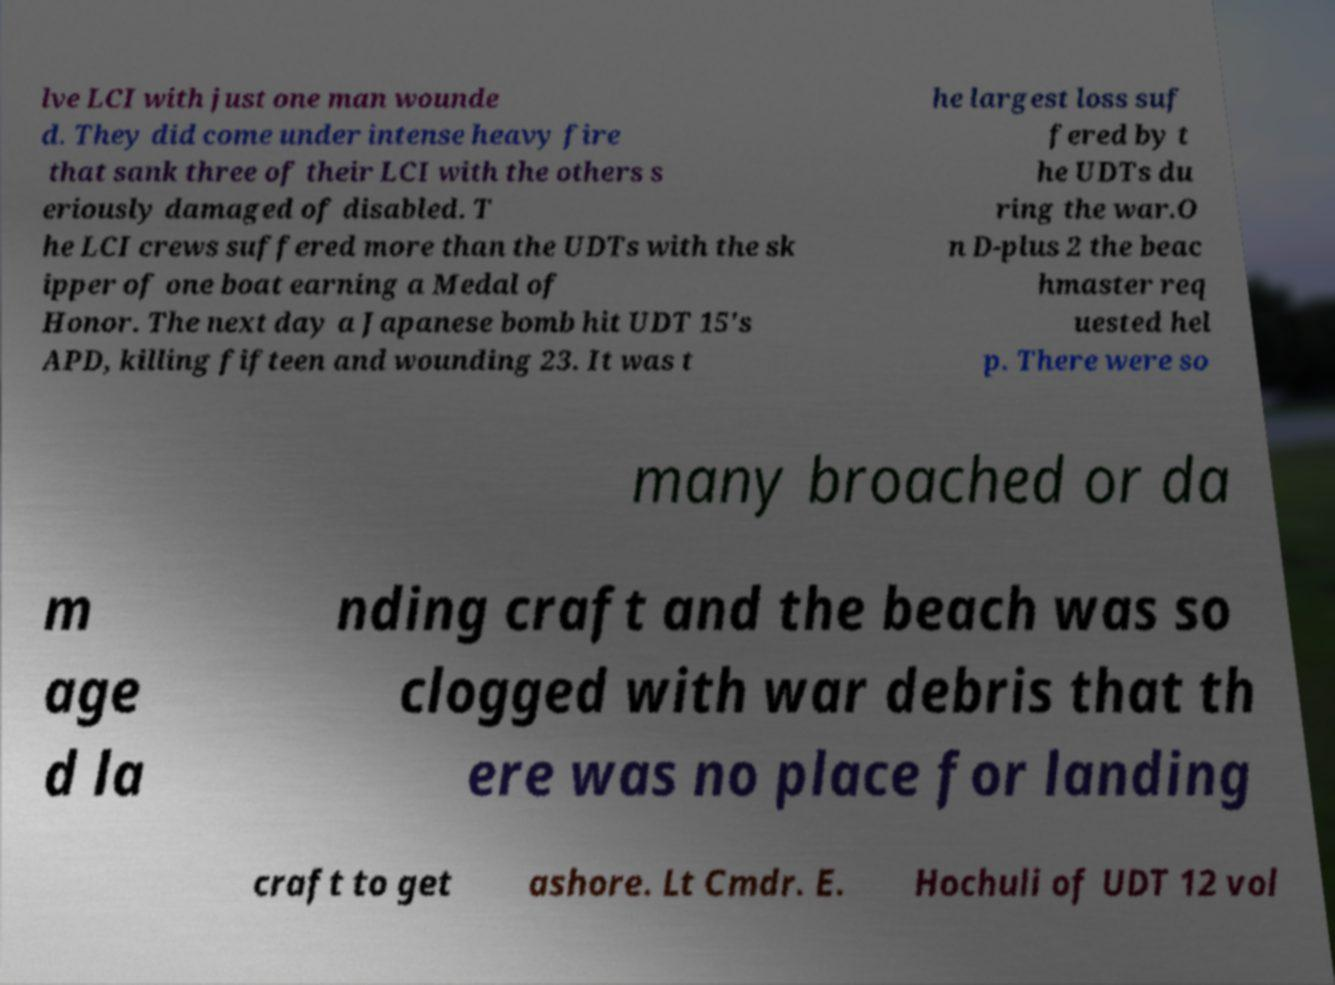There's text embedded in this image that I need extracted. Can you transcribe it verbatim? lve LCI with just one man wounde d. They did come under intense heavy fire that sank three of their LCI with the others s eriously damaged of disabled. T he LCI crews suffered more than the UDTs with the sk ipper of one boat earning a Medal of Honor. The next day a Japanese bomb hit UDT 15's APD, killing fifteen and wounding 23. It was t he largest loss suf fered by t he UDTs du ring the war.O n D-plus 2 the beac hmaster req uested hel p. There were so many broached or da m age d la nding craft and the beach was so clogged with war debris that th ere was no place for landing craft to get ashore. Lt Cmdr. E. Hochuli of UDT 12 vol 